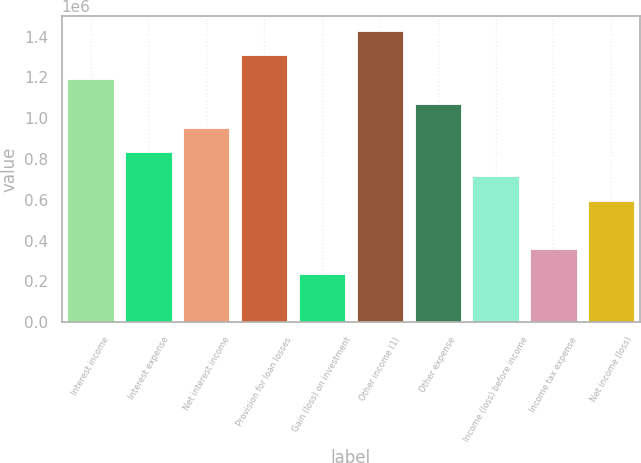<chart> <loc_0><loc_0><loc_500><loc_500><bar_chart><fcel>Interest income<fcel>Interest expense<fcel>Net interest income<fcel>Provision for loan losses<fcel>Gain (loss) on investment<fcel>Other income (1)<fcel>Other expense<fcel>Income (loss) before income<fcel>Income tax expense<fcel>Net income (loss)<nl><fcel>1.19076e+06<fcel>833533<fcel>952609<fcel>1.30984e+06<fcel>238152<fcel>1.42891e+06<fcel>1.07168e+06<fcel>714457<fcel>357228<fcel>595381<nl></chart> 